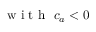Convert formula to latex. <formula><loc_0><loc_0><loc_500><loc_500>w i t h \ c _ { a } < 0</formula> 